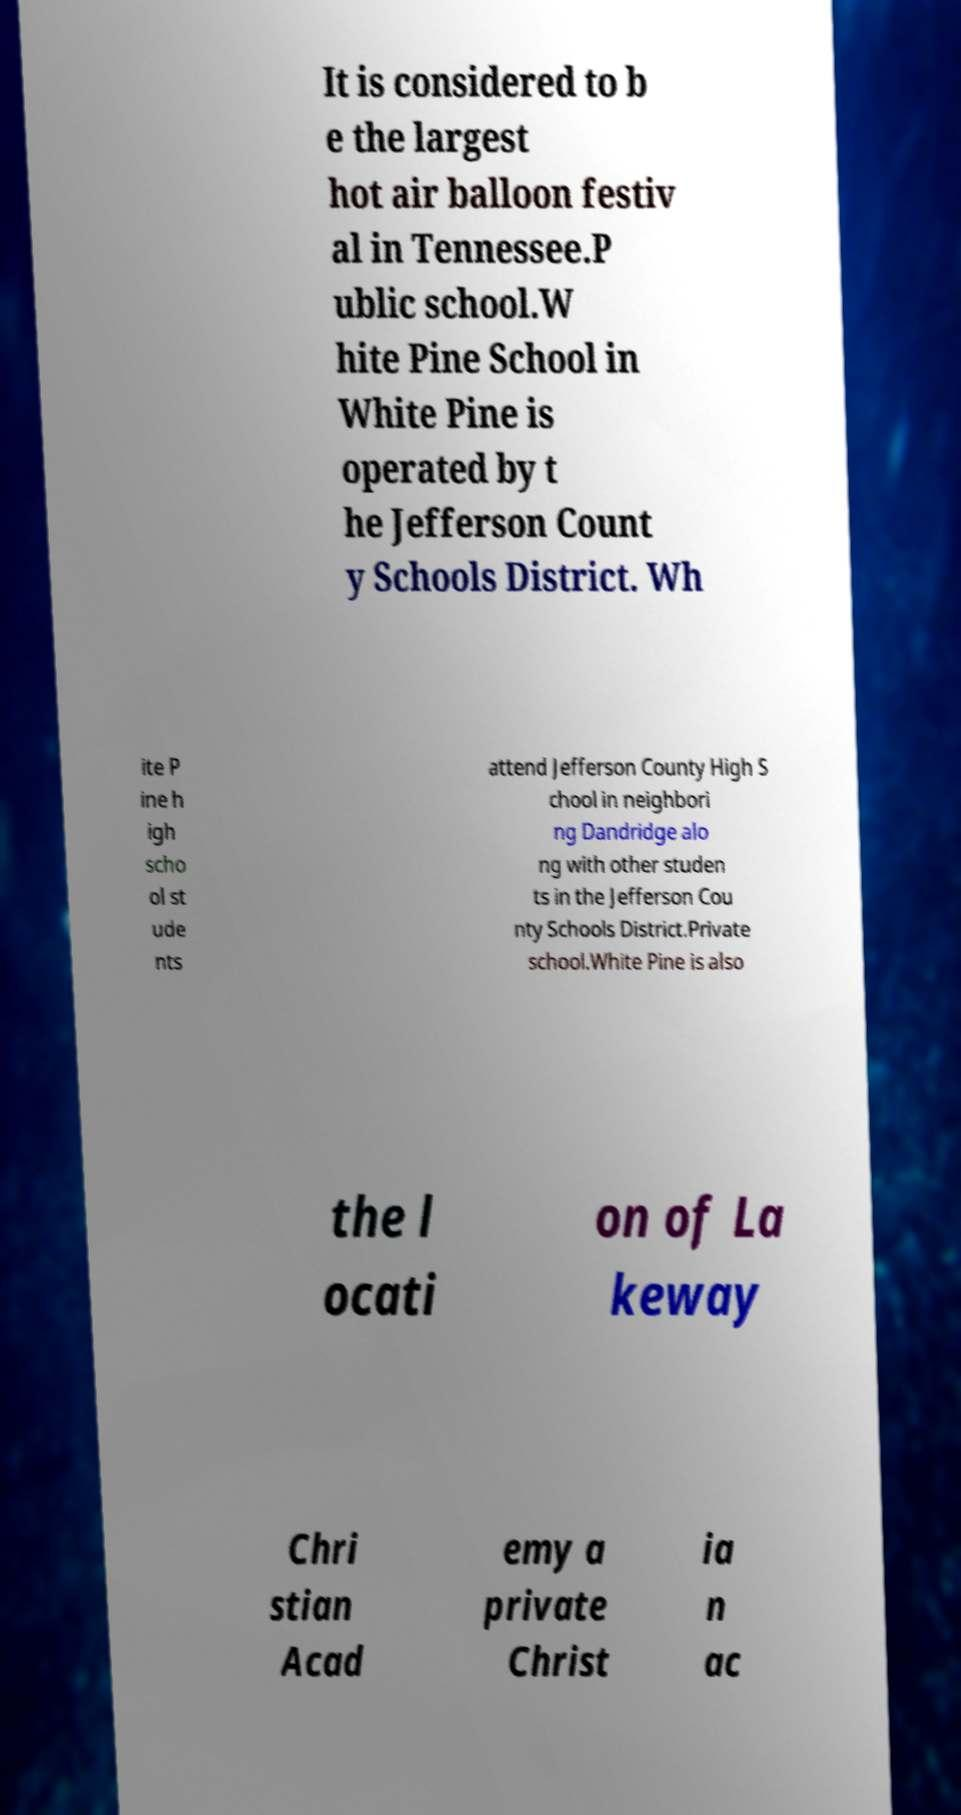Can you accurately transcribe the text from the provided image for me? It is considered to b e the largest hot air balloon festiv al in Tennessee.P ublic school.W hite Pine School in White Pine is operated by t he Jefferson Count y Schools District. Wh ite P ine h igh scho ol st ude nts attend Jefferson County High S chool in neighbori ng Dandridge alo ng with other studen ts in the Jefferson Cou nty Schools District.Private school.White Pine is also the l ocati on of La keway Chri stian Acad emy a private Christ ia n ac 